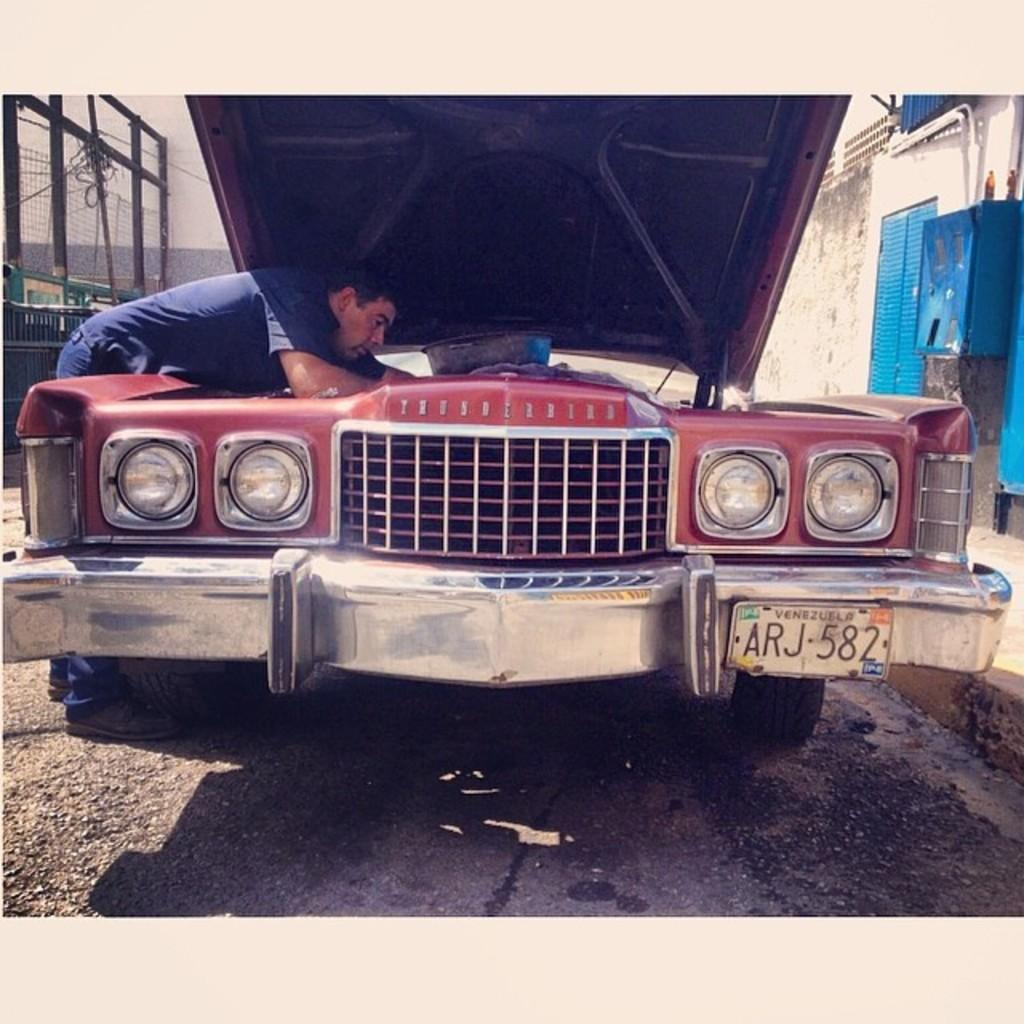Who is present in the image? There is a person in the image. Where is the person located in the image? The person is on the left side of the image. What is the person doing in the image? The person is looking into a car hood. What is the setting of the image? The image is set on a road. What can be seen on either side of the road? There is a wall on one side of the road and a fence on the other side. What type of books can be found in the library in the image? There is no library present in the image; it features a person looking into a car hood on a road with a wall and a fence on either side. 